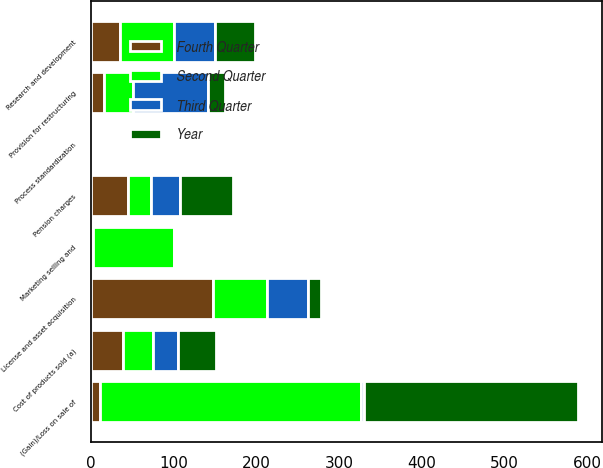Convert chart. <chart><loc_0><loc_0><loc_500><loc_500><stacked_bar_chart><ecel><fcel>Cost of products sold (a)<fcel>Process standardization<fcel>Marketing selling and<fcel>License and asset acquisition<fcel>Research and development<fcel>Provision for restructuring<fcel>(Gain)/Loss on sale of<fcel>Pension charges<nl><fcel>Year<fcel>45<fcel>3<fcel>3<fcel>15<fcel>48<fcel>21<fcel>259<fcel>64<nl><fcel>Fourth Quarter<fcel>39<fcel>3<fcel>3<fcel>148<fcel>35.5<fcel>16<fcel>12<fcel>45<nl><fcel>Second Quarter<fcel>36<fcel>2<fcel>98<fcel>65<fcel>65<fcel>35<fcel>315<fcel>28<nl><fcel>Third Quarter<fcel>31<fcel>1<fcel>1<fcel>50<fcel>50<fcel>91<fcel>3<fcel>35.5<nl></chart> 